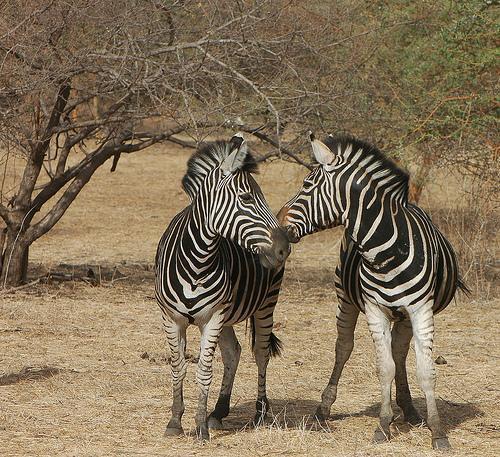How many zebra are there?
Give a very brief answer. 2. 